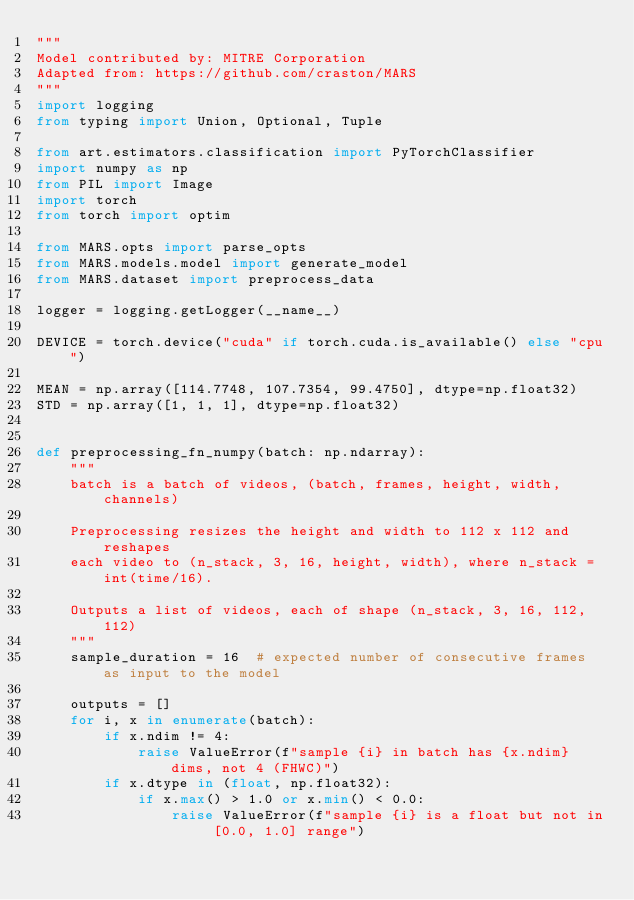Convert code to text. <code><loc_0><loc_0><loc_500><loc_500><_Python_>"""
Model contributed by: MITRE Corporation
Adapted from: https://github.com/craston/MARS
"""
import logging
from typing import Union, Optional, Tuple

from art.estimators.classification import PyTorchClassifier
import numpy as np
from PIL import Image
import torch
from torch import optim

from MARS.opts import parse_opts
from MARS.models.model import generate_model
from MARS.dataset import preprocess_data

logger = logging.getLogger(__name__)

DEVICE = torch.device("cuda" if torch.cuda.is_available() else "cpu")

MEAN = np.array([114.7748, 107.7354, 99.4750], dtype=np.float32)
STD = np.array([1, 1, 1], dtype=np.float32)


def preprocessing_fn_numpy(batch: np.ndarray):
    """
    batch is a batch of videos, (batch, frames, height, width, channels)

    Preprocessing resizes the height and width to 112 x 112 and reshapes
    each video to (n_stack, 3, 16, height, width), where n_stack = int(time/16).

    Outputs a list of videos, each of shape (n_stack, 3, 16, 112, 112)
    """
    sample_duration = 16  # expected number of consecutive frames as input to the model

    outputs = []
    for i, x in enumerate(batch):
        if x.ndim != 4:
            raise ValueError(f"sample {i} in batch has {x.ndim} dims, not 4 (FHWC)")
        if x.dtype in (float, np.float32):
            if x.max() > 1.0 or x.min() < 0.0:
                raise ValueError(f"sample {i} is a float but not in [0.0, 1.0] range")</code> 